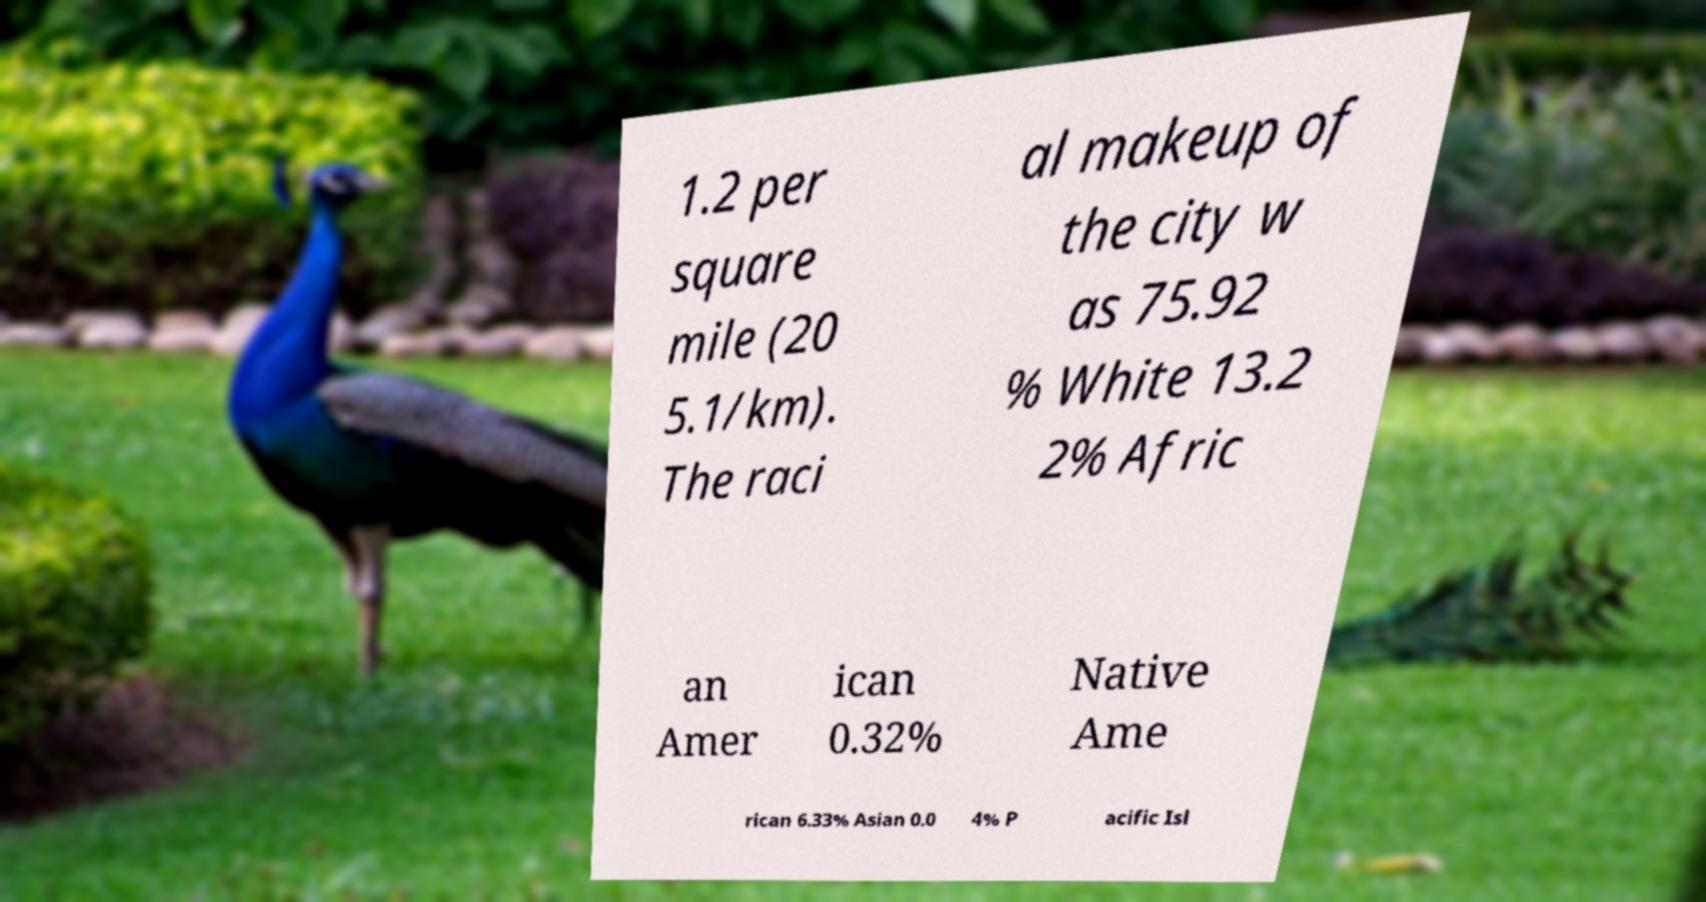Could you assist in decoding the text presented in this image and type it out clearly? 1.2 per square mile (20 5.1/km). The raci al makeup of the city w as 75.92 % White 13.2 2% Afric an Amer ican 0.32% Native Ame rican 6.33% Asian 0.0 4% P acific Isl 